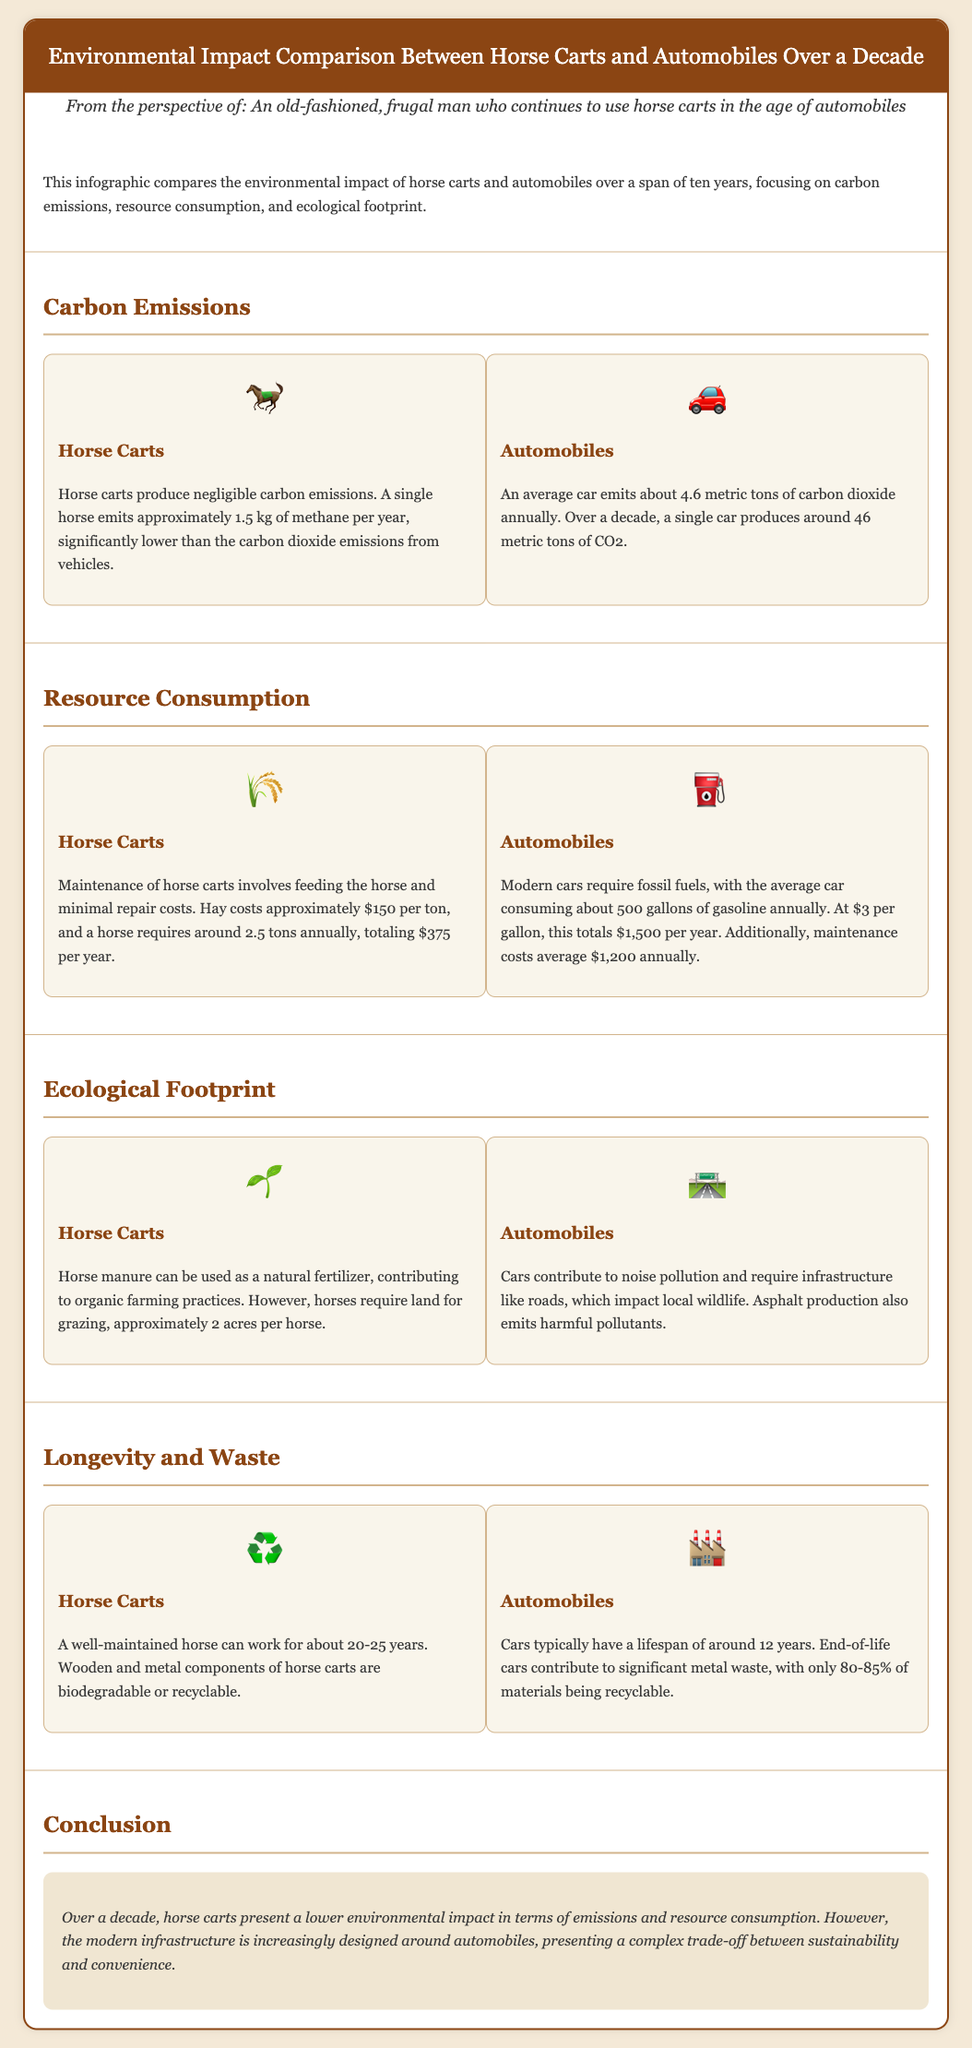What is the annual carbon emission of a single horse? A single horse emits approximately 1.5 kg of methane per year, which is negligible compared to vehicle emissions.
Answer: 1.5 kg How much CO2 does an average car emit annually? An average car emits about 4.6 metric tons of carbon dioxide annually.
Answer: 4.6 metric tons What is the annual cost of feeding a horse? A horse requires around 2.5 tons of hay annually, costing approximately $150 per ton, totaling $375 per year.
Answer: $375 How many gallons of gasoline does an average car consume in a year? The average car consumes about 500 gallons of gasoline annually.
Answer: 500 gallons What is the lifespan of a well-maintained horse? A well-maintained horse can work for about 20-25 years.
Answer: 20-25 years What is the recyclable percentage of end-of-life cars? Only 80-85% of materials in end-of-life cars are recyclable.
Answer: 80-85% Which has a lower ecological footprint, horse carts or automobiles? Horse carts present a lower environmental impact compared to automobiles.
Answer: Horse carts What beneficial use does horse manure have? Horse manure can be used as a natural fertilizer, contributing to organic farming practices.
Answer: Natural fertilizer What unique factor contributes to the complexity of sustainability in modern infrastructure? Modern infrastructure is increasingly designed around automobiles, presenting a trade-off between sustainability and convenience.
Answer: Infrastructure design 